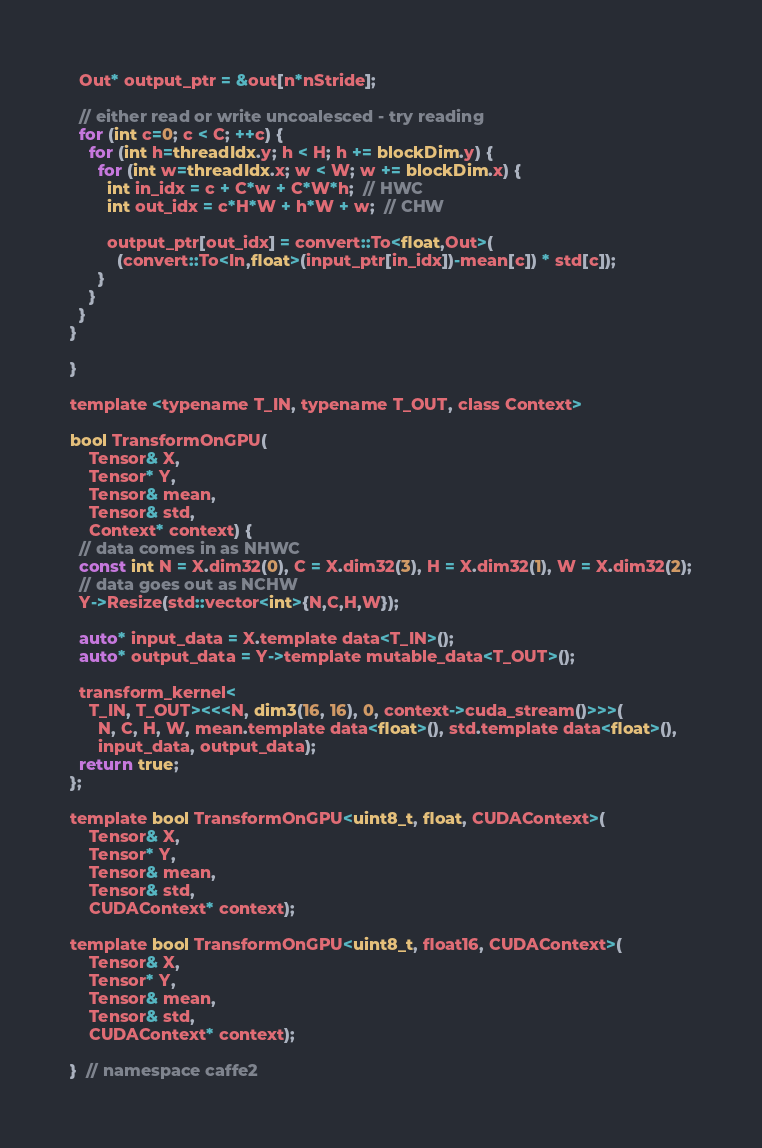<code> <loc_0><loc_0><loc_500><loc_500><_Cuda_>  Out* output_ptr = &out[n*nStride];

  // either read or write uncoalesced - try reading
  for (int c=0; c < C; ++c) {
    for (int h=threadIdx.y; h < H; h += blockDim.y) {
      for (int w=threadIdx.x; w < W; w += blockDim.x) {
        int in_idx = c + C*w + C*W*h;  // HWC
        int out_idx = c*H*W + h*W + w;  // CHW

        output_ptr[out_idx] = convert::To<float,Out>(
          (convert::To<In,float>(input_ptr[in_idx])-mean[c]) * std[c]);
      }
    }
  }
}

}

template <typename T_IN, typename T_OUT, class Context>

bool TransformOnGPU(
    Tensor& X,
    Tensor* Y,
    Tensor& mean,
    Tensor& std,
    Context* context) {
  // data comes in as NHWC
  const int N = X.dim32(0), C = X.dim32(3), H = X.dim32(1), W = X.dim32(2);
  // data goes out as NCHW
  Y->Resize(std::vector<int>{N,C,H,W});

  auto* input_data = X.template data<T_IN>();
  auto* output_data = Y->template mutable_data<T_OUT>();

  transform_kernel<
    T_IN, T_OUT><<<N, dim3(16, 16), 0, context->cuda_stream()>>>(
      N, C, H, W, mean.template data<float>(), std.template data<float>(),
      input_data, output_data);
  return true;
};

template bool TransformOnGPU<uint8_t, float, CUDAContext>(
    Tensor& X,
    Tensor* Y,
    Tensor& mean,
    Tensor& std,
    CUDAContext* context);

template bool TransformOnGPU<uint8_t, float16, CUDAContext>(
    Tensor& X,
    Tensor* Y,
    Tensor& mean,
    Tensor& std,
    CUDAContext* context);

}  // namespace caffe2
</code> 